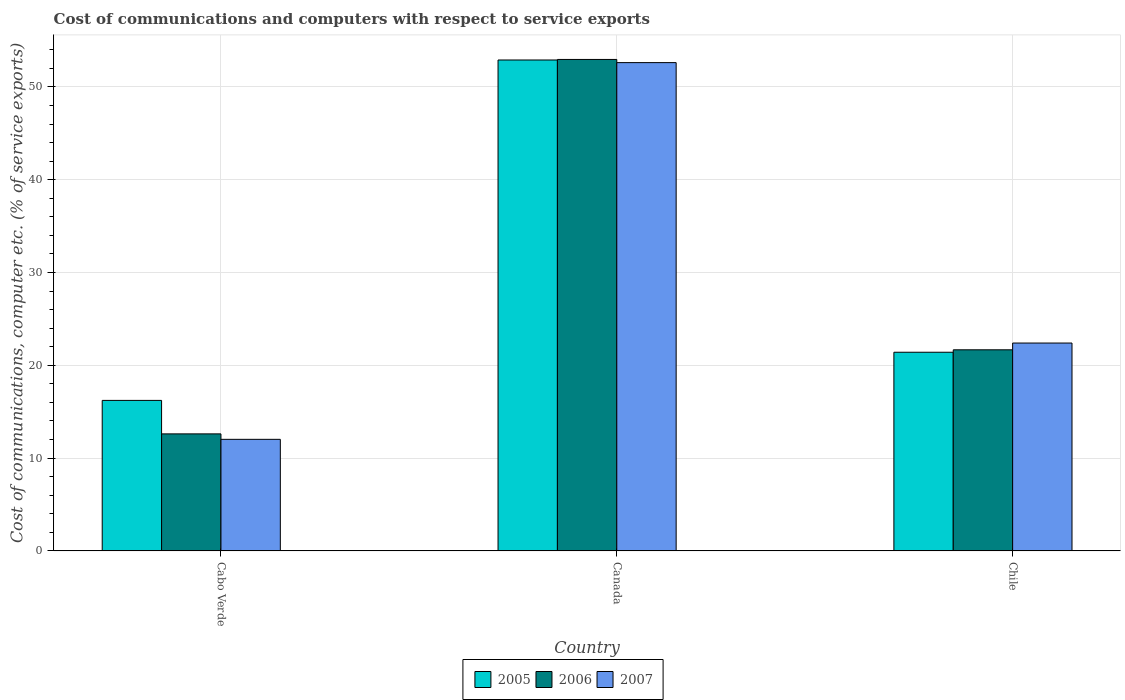Are the number of bars per tick equal to the number of legend labels?
Keep it short and to the point. Yes. How many bars are there on the 1st tick from the right?
Give a very brief answer. 3. What is the label of the 1st group of bars from the left?
Make the answer very short. Cabo Verde. In how many cases, is the number of bars for a given country not equal to the number of legend labels?
Your response must be concise. 0. What is the cost of communications and computers in 2005 in Cabo Verde?
Keep it short and to the point. 16.22. Across all countries, what is the maximum cost of communications and computers in 2006?
Provide a short and direct response. 52.96. Across all countries, what is the minimum cost of communications and computers in 2005?
Ensure brevity in your answer.  16.22. In which country was the cost of communications and computers in 2006 minimum?
Your response must be concise. Cabo Verde. What is the total cost of communications and computers in 2006 in the graph?
Give a very brief answer. 87.24. What is the difference between the cost of communications and computers in 2005 in Cabo Verde and that in Canada?
Offer a terse response. -36.68. What is the difference between the cost of communications and computers in 2007 in Chile and the cost of communications and computers in 2006 in Canada?
Ensure brevity in your answer.  -30.56. What is the average cost of communications and computers in 2006 per country?
Offer a terse response. 29.08. What is the difference between the cost of communications and computers of/in 2007 and cost of communications and computers of/in 2005 in Chile?
Ensure brevity in your answer.  0.99. What is the ratio of the cost of communications and computers in 2006 in Canada to that in Chile?
Offer a very short reply. 2.44. Is the difference between the cost of communications and computers in 2007 in Cabo Verde and Chile greater than the difference between the cost of communications and computers in 2005 in Cabo Verde and Chile?
Your response must be concise. No. What is the difference between the highest and the second highest cost of communications and computers in 2005?
Keep it short and to the point. -36.68. What is the difference between the highest and the lowest cost of communications and computers in 2005?
Keep it short and to the point. 36.68. How many countries are there in the graph?
Make the answer very short. 3. What is the difference between two consecutive major ticks on the Y-axis?
Offer a very short reply. 10. Does the graph contain any zero values?
Ensure brevity in your answer.  No. Where does the legend appear in the graph?
Your answer should be very brief. Bottom center. How many legend labels are there?
Keep it short and to the point. 3. How are the legend labels stacked?
Give a very brief answer. Horizontal. What is the title of the graph?
Offer a terse response. Cost of communications and computers with respect to service exports. What is the label or title of the X-axis?
Keep it short and to the point. Country. What is the label or title of the Y-axis?
Make the answer very short. Cost of communications, computer etc. (% of service exports). What is the Cost of communications, computer etc. (% of service exports) in 2005 in Cabo Verde?
Give a very brief answer. 16.22. What is the Cost of communications, computer etc. (% of service exports) of 2006 in Cabo Verde?
Provide a short and direct response. 12.61. What is the Cost of communications, computer etc. (% of service exports) of 2007 in Cabo Verde?
Your answer should be compact. 12.02. What is the Cost of communications, computer etc. (% of service exports) of 2005 in Canada?
Offer a terse response. 52.9. What is the Cost of communications, computer etc. (% of service exports) in 2006 in Canada?
Your response must be concise. 52.96. What is the Cost of communications, computer etc. (% of service exports) of 2007 in Canada?
Offer a very short reply. 52.62. What is the Cost of communications, computer etc. (% of service exports) of 2005 in Chile?
Keep it short and to the point. 21.41. What is the Cost of communications, computer etc. (% of service exports) of 2006 in Chile?
Offer a terse response. 21.67. What is the Cost of communications, computer etc. (% of service exports) of 2007 in Chile?
Keep it short and to the point. 22.4. Across all countries, what is the maximum Cost of communications, computer etc. (% of service exports) of 2005?
Your answer should be very brief. 52.9. Across all countries, what is the maximum Cost of communications, computer etc. (% of service exports) in 2006?
Give a very brief answer. 52.96. Across all countries, what is the maximum Cost of communications, computer etc. (% of service exports) in 2007?
Your response must be concise. 52.62. Across all countries, what is the minimum Cost of communications, computer etc. (% of service exports) of 2005?
Your answer should be very brief. 16.22. Across all countries, what is the minimum Cost of communications, computer etc. (% of service exports) in 2006?
Your answer should be very brief. 12.61. Across all countries, what is the minimum Cost of communications, computer etc. (% of service exports) in 2007?
Your answer should be compact. 12.02. What is the total Cost of communications, computer etc. (% of service exports) of 2005 in the graph?
Give a very brief answer. 90.53. What is the total Cost of communications, computer etc. (% of service exports) of 2006 in the graph?
Provide a succinct answer. 87.24. What is the total Cost of communications, computer etc. (% of service exports) of 2007 in the graph?
Offer a terse response. 87.04. What is the difference between the Cost of communications, computer etc. (% of service exports) of 2005 in Cabo Verde and that in Canada?
Provide a short and direct response. -36.68. What is the difference between the Cost of communications, computer etc. (% of service exports) in 2006 in Cabo Verde and that in Canada?
Your answer should be compact. -40.35. What is the difference between the Cost of communications, computer etc. (% of service exports) of 2007 in Cabo Verde and that in Canada?
Make the answer very short. -40.59. What is the difference between the Cost of communications, computer etc. (% of service exports) in 2005 in Cabo Verde and that in Chile?
Give a very brief answer. -5.19. What is the difference between the Cost of communications, computer etc. (% of service exports) in 2006 in Cabo Verde and that in Chile?
Make the answer very short. -9.06. What is the difference between the Cost of communications, computer etc. (% of service exports) of 2007 in Cabo Verde and that in Chile?
Your answer should be very brief. -10.38. What is the difference between the Cost of communications, computer etc. (% of service exports) in 2005 in Canada and that in Chile?
Offer a very short reply. 31.49. What is the difference between the Cost of communications, computer etc. (% of service exports) in 2006 in Canada and that in Chile?
Give a very brief answer. 31.29. What is the difference between the Cost of communications, computer etc. (% of service exports) in 2007 in Canada and that in Chile?
Your answer should be very brief. 30.22. What is the difference between the Cost of communications, computer etc. (% of service exports) of 2005 in Cabo Verde and the Cost of communications, computer etc. (% of service exports) of 2006 in Canada?
Your answer should be compact. -36.74. What is the difference between the Cost of communications, computer etc. (% of service exports) of 2005 in Cabo Verde and the Cost of communications, computer etc. (% of service exports) of 2007 in Canada?
Your response must be concise. -36.4. What is the difference between the Cost of communications, computer etc. (% of service exports) in 2006 in Cabo Verde and the Cost of communications, computer etc. (% of service exports) in 2007 in Canada?
Provide a succinct answer. -40. What is the difference between the Cost of communications, computer etc. (% of service exports) in 2005 in Cabo Verde and the Cost of communications, computer etc. (% of service exports) in 2006 in Chile?
Your response must be concise. -5.45. What is the difference between the Cost of communications, computer etc. (% of service exports) of 2005 in Cabo Verde and the Cost of communications, computer etc. (% of service exports) of 2007 in Chile?
Your answer should be compact. -6.18. What is the difference between the Cost of communications, computer etc. (% of service exports) of 2006 in Cabo Verde and the Cost of communications, computer etc. (% of service exports) of 2007 in Chile?
Give a very brief answer. -9.79. What is the difference between the Cost of communications, computer etc. (% of service exports) in 2005 in Canada and the Cost of communications, computer etc. (% of service exports) in 2006 in Chile?
Offer a terse response. 31.23. What is the difference between the Cost of communications, computer etc. (% of service exports) of 2005 in Canada and the Cost of communications, computer etc. (% of service exports) of 2007 in Chile?
Provide a succinct answer. 30.5. What is the difference between the Cost of communications, computer etc. (% of service exports) in 2006 in Canada and the Cost of communications, computer etc. (% of service exports) in 2007 in Chile?
Offer a terse response. 30.56. What is the average Cost of communications, computer etc. (% of service exports) of 2005 per country?
Your response must be concise. 30.18. What is the average Cost of communications, computer etc. (% of service exports) of 2006 per country?
Offer a terse response. 29.08. What is the average Cost of communications, computer etc. (% of service exports) of 2007 per country?
Keep it short and to the point. 29.01. What is the difference between the Cost of communications, computer etc. (% of service exports) in 2005 and Cost of communications, computer etc. (% of service exports) in 2006 in Cabo Verde?
Offer a terse response. 3.61. What is the difference between the Cost of communications, computer etc. (% of service exports) in 2005 and Cost of communications, computer etc. (% of service exports) in 2007 in Cabo Verde?
Keep it short and to the point. 4.19. What is the difference between the Cost of communications, computer etc. (% of service exports) of 2006 and Cost of communications, computer etc. (% of service exports) of 2007 in Cabo Verde?
Provide a short and direct response. 0.59. What is the difference between the Cost of communications, computer etc. (% of service exports) of 2005 and Cost of communications, computer etc. (% of service exports) of 2006 in Canada?
Your response must be concise. -0.06. What is the difference between the Cost of communications, computer etc. (% of service exports) in 2005 and Cost of communications, computer etc. (% of service exports) in 2007 in Canada?
Offer a very short reply. 0.28. What is the difference between the Cost of communications, computer etc. (% of service exports) of 2006 and Cost of communications, computer etc. (% of service exports) of 2007 in Canada?
Keep it short and to the point. 0.34. What is the difference between the Cost of communications, computer etc. (% of service exports) in 2005 and Cost of communications, computer etc. (% of service exports) in 2006 in Chile?
Offer a terse response. -0.26. What is the difference between the Cost of communications, computer etc. (% of service exports) of 2005 and Cost of communications, computer etc. (% of service exports) of 2007 in Chile?
Make the answer very short. -0.99. What is the difference between the Cost of communications, computer etc. (% of service exports) in 2006 and Cost of communications, computer etc. (% of service exports) in 2007 in Chile?
Your answer should be compact. -0.73. What is the ratio of the Cost of communications, computer etc. (% of service exports) in 2005 in Cabo Verde to that in Canada?
Offer a very short reply. 0.31. What is the ratio of the Cost of communications, computer etc. (% of service exports) in 2006 in Cabo Verde to that in Canada?
Your answer should be very brief. 0.24. What is the ratio of the Cost of communications, computer etc. (% of service exports) of 2007 in Cabo Verde to that in Canada?
Your answer should be very brief. 0.23. What is the ratio of the Cost of communications, computer etc. (% of service exports) of 2005 in Cabo Verde to that in Chile?
Give a very brief answer. 0.76. What is the ratio of the Cost of communications, computer etc. (% of service exports) of 2006 in Cabo Verde to that in Chile?
Offer a very short reply. 0.58. What is the ratio of the Cost of communications, computer etc. (% of service exports) in 2007 in Cabo Verde to that in Chile?
Ensure brevity in your answer.  0.54. What is the ratio of the Cost of communications, computer etc. (% of service exports) in 2005 in Canada to that in Chile?
Give a very brief answer. 2.47. What is the ratio of the Cost of communications, computer etc. (% of service exports) in 2006 in Canada to that in Chile?
Your answer should be compact. 2.44. What is the ratio of the Cost of communications, computer etc. (% of service exports) of 2007 in Canada to that in Chile?
Ensure brevity in your answer.  2.35. What is the difference between the highest and the second highest Cost of communications, computer etc. (% of service exports) of 2005?
Your answer should be very brief. 31.49. What is the difference between the highest and the second highest Cost of communications, computer etc. (% of service exports) of 2006?
Keep it short and to the point. 31.29. What is the difference between the highest and the second highest Cost of communications, computer etc. (% of service exports) in 2007?
Your answer should be very brief. 30.22. What is the difference between the highest and the lowest Cost of communications, computer etc. (% of service exports) of 2005?
Give a very brief answer. 36.68. What is the difference between the highest and the lowest Cost of communications, computer etc. (% of service exports) of 2006?
Provide a short and direct response. 40.35. What is the difference between the highest and the lowest Cost of communications, computer etc. (% of service exports) of 2007?
Your answer should be very brief. 40.59. 